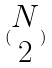<formula> <loc_0><loc_0><loc_500><loc_500>( \begin{matrix} N \\ 2 \end{matrix} )</formula> 